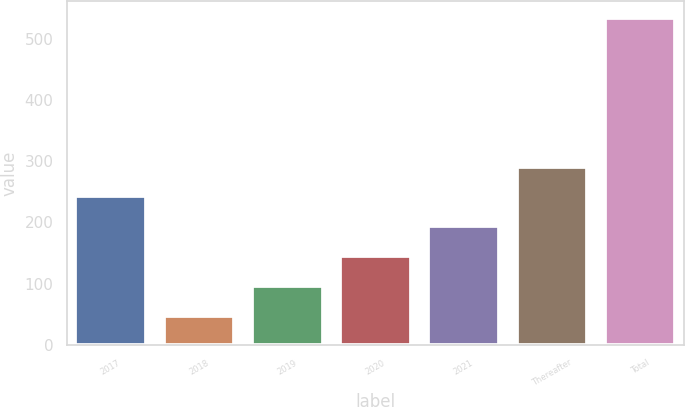<chart> <loc_0><loc_0><loc_500><loc_500><bar_chart><fcel>2017<fcel>2018<fcel>2019<fcel>2020<fcel>2021<fcel>Thereafter<fcel>Total<nl><fcel>242.48<fcel>47.6<fcel>96.32<fcel>145.04<fcel>193.76<fcel>291.2<fcel>534.8<nl></chart> 